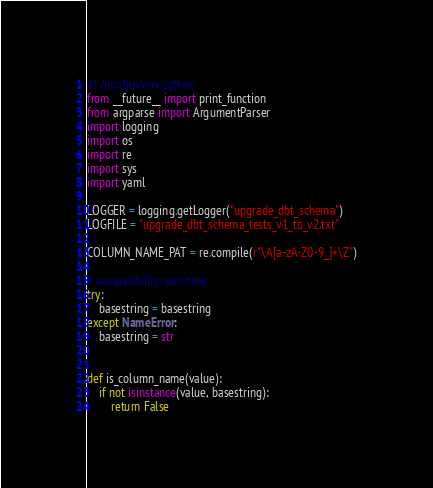<code> <loc_0><loc_0><loc_500><loc_500><_Python_>#! /usr/bin/env python
from __future__ import print_function
from argparse import ArgumentParser
import logging
import os
import re
import sys
import yaml

LOGGER = logging.getLogger("upgrade_dbt_schema")
LOGFILE = "upgrade_dbt_schema_tests_v1_to_v2.txt"

COLUMN_NAME_PAT = re.compile(r"\A[a-zA-Z0-9_]+\Z")

# compatibility nonsense
try:
    basestring = basestring
except NameError:
    basestring = str


def is_column_name(value):
    if not isinstance(value, basestring):
        return False</code> 